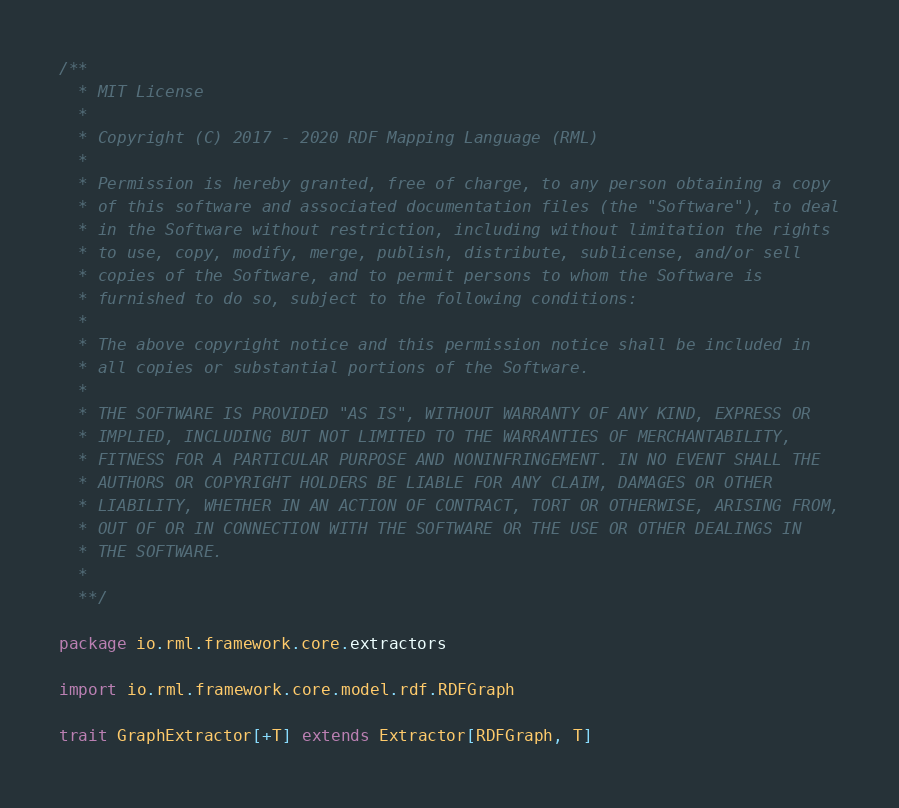Convert code to text. <code><loc_0><loc_0><loc_500><loc_500><_Scala_>/**
  * MIT License
  *
  * Copyright (C) 2017 - 2020 RDF Mapping Language (RML)
  *
  * Permission is hereby granted, free of charge, to any person obtaining a copy
  * of this software and associated documentation files (the "Software"), to deal
  * in the Software without restriction, including without limitation the rights
  * to use, copy, modify, merge, publish, distribute, sublicense, and/or sell
  * copies of the Software, and to permit persons to whom the Software is
  * furnished to do so, subject to the following conditions:
  *
  * The above copyright notice and this permission notice shall be included in
  * all copies or substantial portions of the Software.
  *
  * THE SOFTWARE IS PROVIDED "AS IS", WITHOUT WARRANTY OF ANY KIND, EXPRESS OR
  * IMPLIED, INCLUDING BUT NOT LIMITED TO THE WARRANTIES OF MERCHANTABILITY,
  * FITNESS FOR A PARTICULAR PURPOSE AND NONINFRINGEMENT. IN NO EVENT SHALL THE
  * AUTHORS OR COPYRIGHT HOLDERS BE LIABLE FOR ANY CLAIM, DAMAGES OR OTHER
  * LIABILITY, WHETHER IN AN ACTION OF CONTRACT, TORT OR OTHERWISE, ARISING FROM,
  * OUT OF OR IN CONNECTION WITH THE SOFTWARE OR THE USE OR OTHER DEALINGS IN
  * THE SOFTWARE.
  *
  **/

package io.rml.framework.core.extractors

import io.rml.framework.core.model.rdf.RDFGraph

trait GraphExtractor[+T] extends Extractor[RDFGraph, T]
</code> 